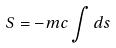<formula> <loc_0><loc_0><loc_500><loc_500>S = - m c \int d s</formula> 